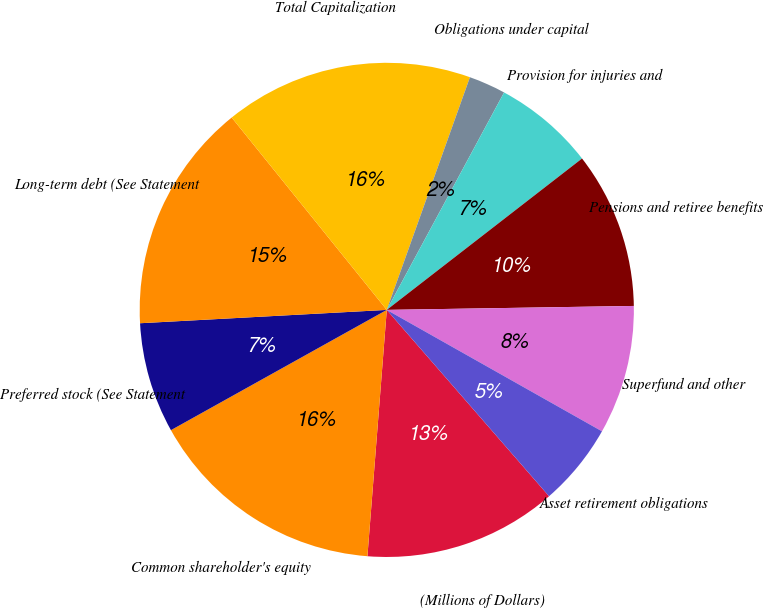Convert chart. <chart><loc_0><loc_0><loc_500><loc_500><pie_chart><fcel>(Millions of Dollars)<fcel>Common shareholder's equity<fcel>Preferred stock (See Statement<fcel>Long-term debt (See Statement<fcel>Total Capitalization<fcel>Obligations under capital<fcel>Provision for injuries and<fcel>Pensions and retiree benefits<fcel>Superfund and other<fcel>Asset retirement obligations<nl><fcel>12.65%<fcel>15.66%<fcel>7.23%<fcel>15.06%<fcel>16.26%<fcel>2.41%<fcel>6.63%<fcel>10.24%<fcel>8.43%<fcel>5.42%<nl></chart> 